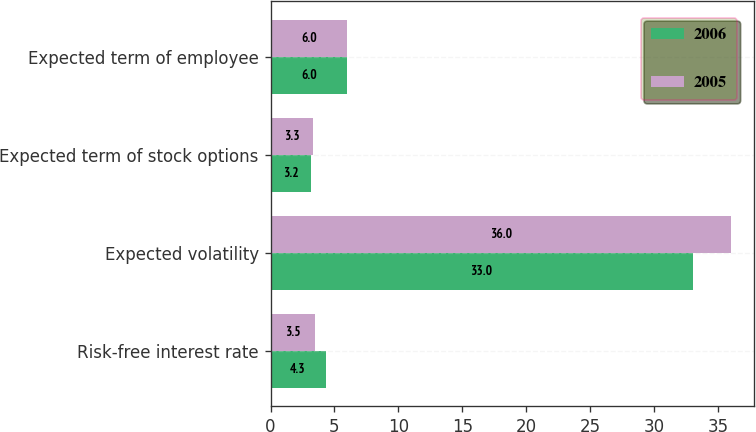Convert chart to OTSL. <chart><loc_0><loc_0><loc_500><loc_500><stacked_bar_chart><ecel><fcel>Risk-free interest rate<fcel>Expected volatility<fcel>Expected term of stock options<fcel>Expected term of employee<nl><fcel>2006<fcel>4.3<fcel>33<fcel>3.2<fcel>6<nl><fcel>2005<fcel>3.5<fcel>36<fcel>3.3<fcel>6<nl></chart> 